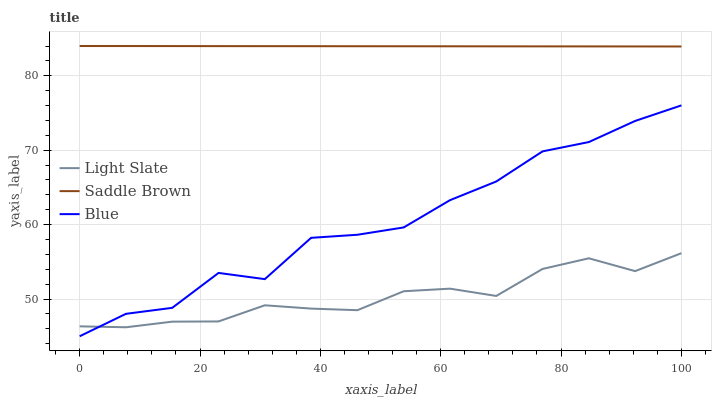Does Light Slate have the minimum area under the curve?
Answer yes or no. Yes. Does Saddle Brown have the maximum area under the curve?
Answer yes or no. Yes. Does Blue have the minimum area under the curve?
Answer yes or no. No. Does Blue have the maximum area under the curve?
Answer yes or no. No. Is Saddle Brown the smoothest?
Answer yes or no. Yes. Is Blue the roughest?
Answer yes or no. Yes. Is Blue the smoothest?
Answer yes or no. No. Is Saddle Brown the roughest?
Answer yes or no. No. Does Blue have the lowest value?
Answer yes or no. Yes. Does Saddle Brown have the lowest value?
Answer yes or no. No. Does Saddle Brown have the highest value?
Answer yes or no. Yes. Does Blue have the highest value?
Answer yes or no. No. Is Light Slate less than Saddle Brown?
Answer yes or no. Yes. Is Saddle Brown greater than Blue?
Answer yes or no. Yes. Does Light Slate intersect Blue?
Answer yes or no. Yes. Is Light Slate less than Blue?
Answer yes or no. No. Is Light Slate greater than Blue?
Answer yes or no. No. Does Light Slate intersect Saddle Brown?
Answer yes or no. No. 